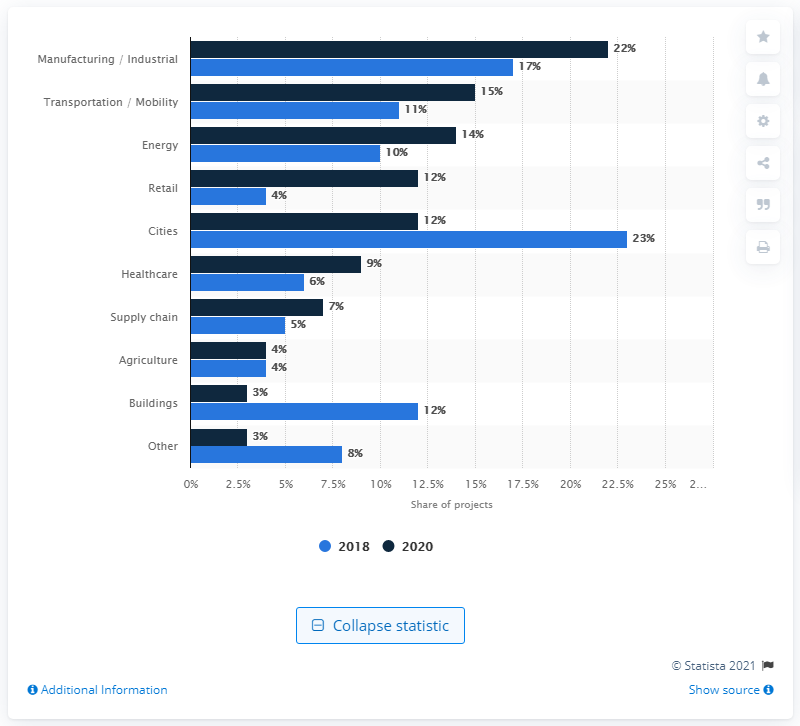List a handful of essential elements in this visual. In 2020, the IoT enterprise projects in the manufacturing and industrial segment accounted for approximately 22% of the total number of projects. 